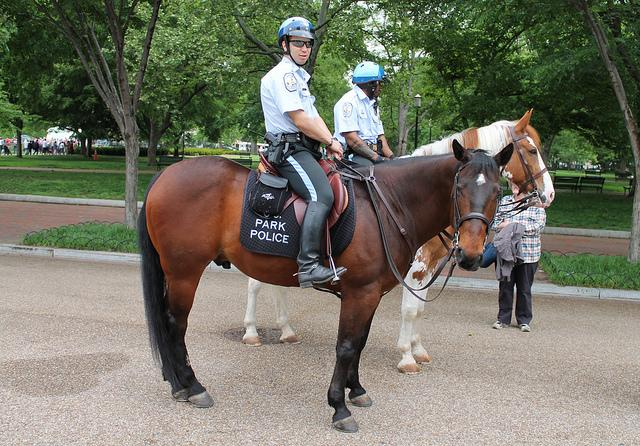Where are these policemen patrolling? Please explain your reasoning. inside park. In looking at the background with its trees, grass, benches and people congregating, it is apparent that it is a park.  the police are policing inside this park. 